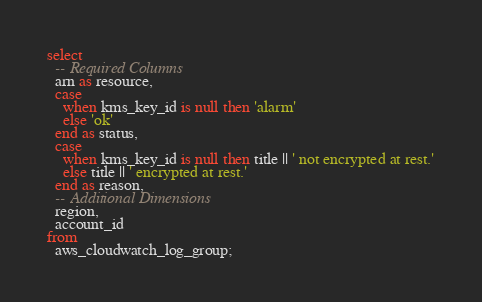Convert code to text. <code><loc_0><loc_0><loc_500><loc_500><_SQL_>select
  -- Required Columns
  arn as resource,
  case
    when kms_key_id is null then 'alarm'
    else 'ok'
  end as status,
  case
    when kms_key_id is null then title || ' not encrypted at rest.'
    else title || ' encrypted at rest.'
  end as reason,
  -- Additional Dimensions
  region,
  account_id
from
  aws_cloudwatch_log_group;</code> 